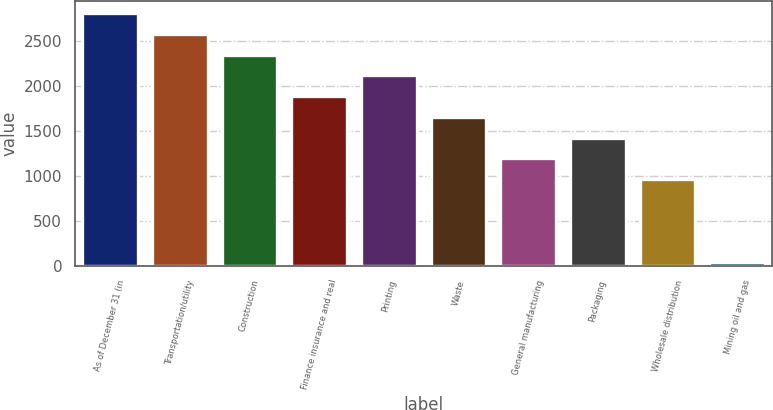Convert chart. <chart><loc_0><loc_0><loc_500><loc_500><bar_chart><fcel>As of December 31 (in<fcel>Transportation/utility<fcel>Construction<fcel>Finance insurance and real<fcel>Printing<fcel>Waste<fcel>General manufacturing<fcel>Packaging<fcel>Wholesale distribution<fcel>Mining oil and gas<nl><fcel>2814.62<fcel>2583.46<fcel>2352.3<fcel>1889.98<fcel>2121.14<fcel>1658.82<fcel>1196.5<fcel>1427.66<fcel>965.34<fcel>40.7<nl></chart> 